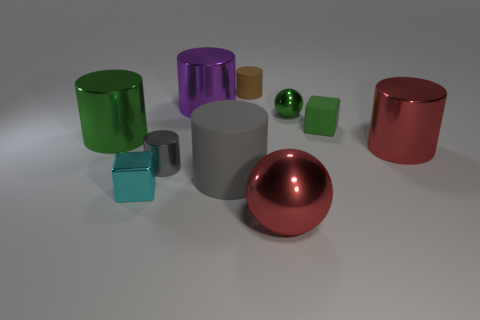Subtract 2 cylinders. How many cylinders are left? 4 Subtract all brown cylinders. How many cylinders are left? 5 Subtract all red metal cylinders. How many cylinders are left? 5 Subtract all blue cylinders. Subtract all yellow balls. How many cylinders are left? 6 Subtract all cylinders. How many objects are left? 4 Add 8 tiny gray cylinders. How many tiny gray cylinders exist? 9 Subtract 0 purple balls. How many objects are left? 10 Subtract all purple cylinders. Subtract all purple metal objects. How many objects are left? 8 Add 5 small cyan cubes. How many small cyan cubes are left? 6 